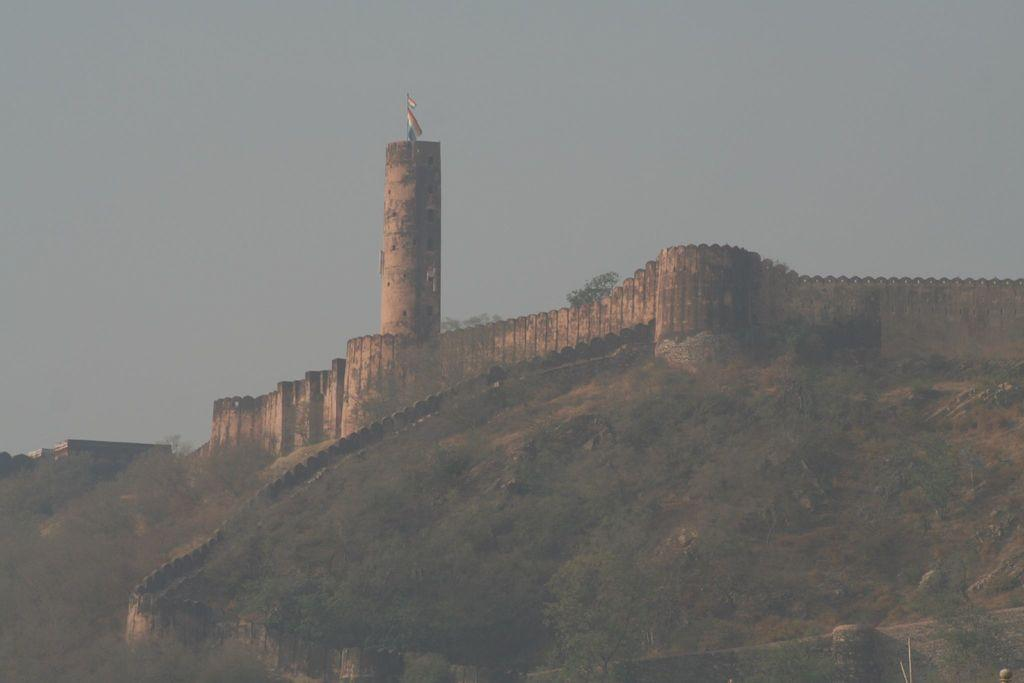What type of natural elements can be seen in the image? There are trees and rocks in the image. What type of structure is present in the image? There is a fort in the image. What is attached to the fort in the image? There is a flag in the image. What can be seen in the background of the image? The sky is visible in the background of the image. How many rings are visible on the trees in the image? There are no rings visible on the trees in the image. Rings are typically found on tree trunks to indicate the tree's age, but we cannot see the trunks in this image. 